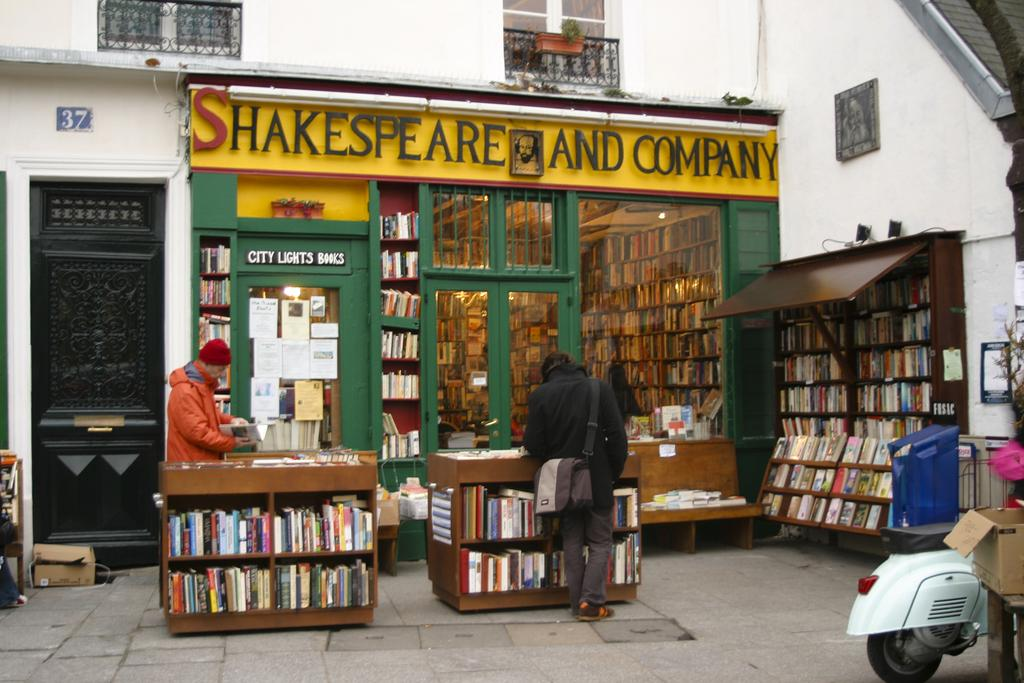<image>
Offer a succinct explanation of the picture presented. A bookstore that is partly outdoors called Shakespeare and Company. 